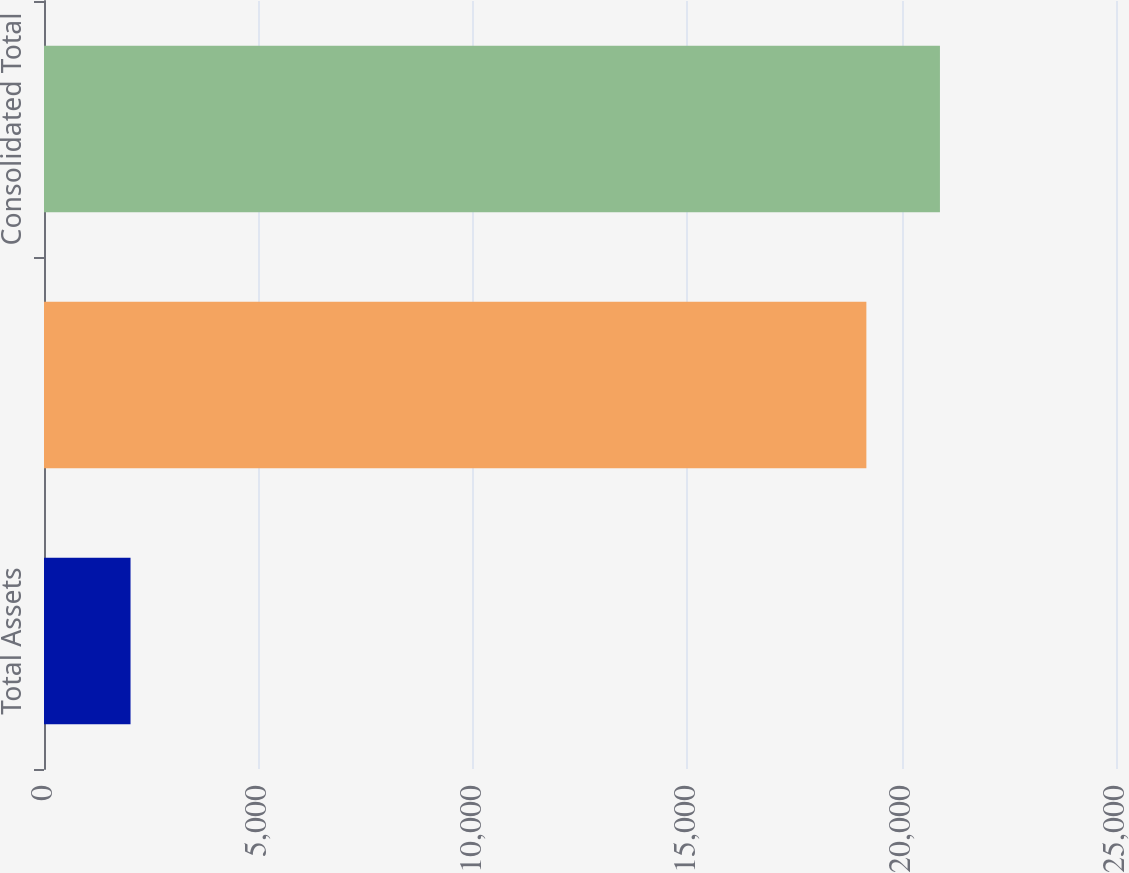<chart> <loc_0><loc_0><loc_500><loc_500><bar_chart><fcel>Total Assets<fcel>Segment total<fcel>Consolidated Total<nl><fcel>2018<fcel>19178.3<fcel>20894.3<nl></chart> 